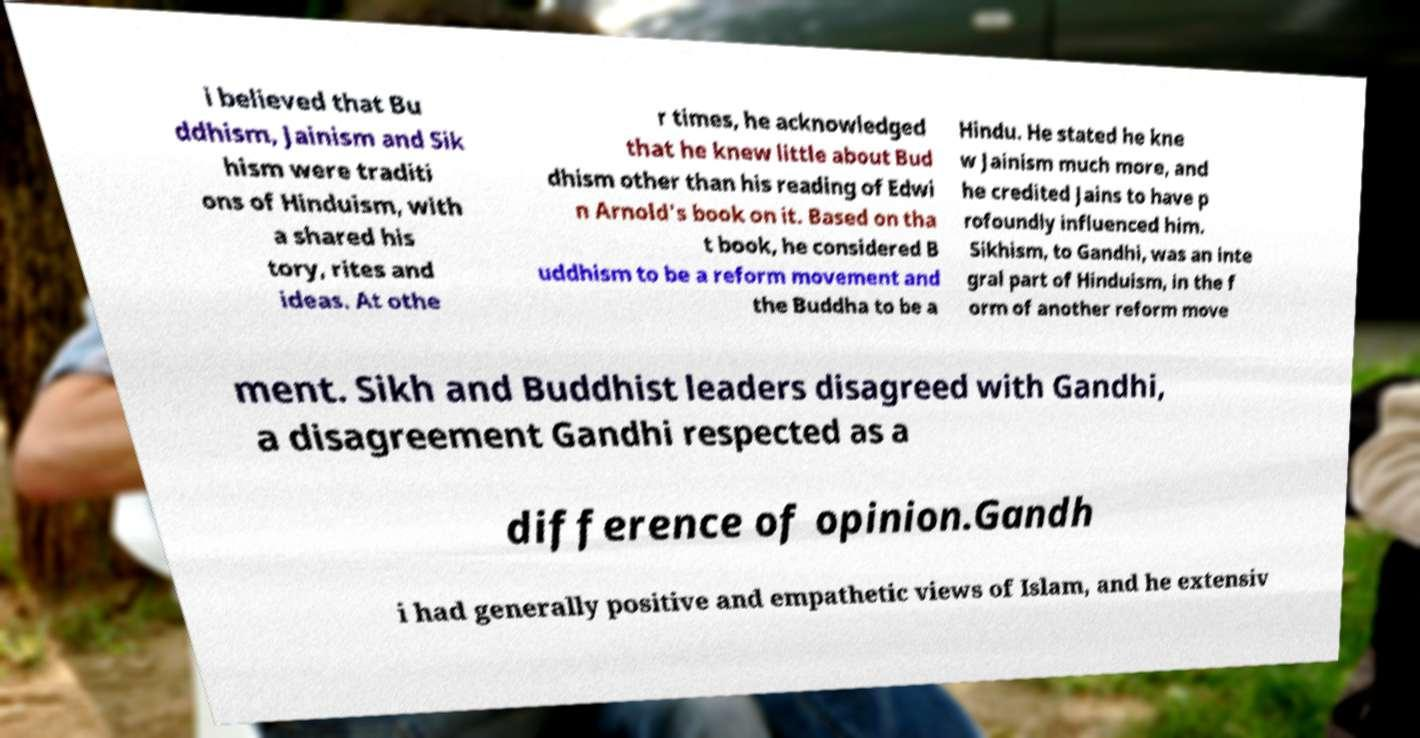What messages or text are displayed in this image? I need them in a readable, typed format. i believed that Bu ddhism, Jainism and Sik hism were traditi ons of Hinduism, with a shared his tory, rites and ideas. At othe r times, he acknowledged that he knew little about Bud dhism other than his reading of Edwi n Arnold's book on it. Based on tha t book, he considered B uddhism to be a reform movement and the Buddha to be a Hindu. He stated he kne w Jainism much more, and he credited Jains to have p rofoundly influenced him. Sikhism, to Gandhi, was an inte gral part of Hinduism, in the f orm of another reform move ment. Sikh and Buddhist leaders disagreed with Gandhi, a disagreement Gandhi respected as a difference of opinion.Gandh i had generally positive and empathetic views of Islam, and he extensiv 